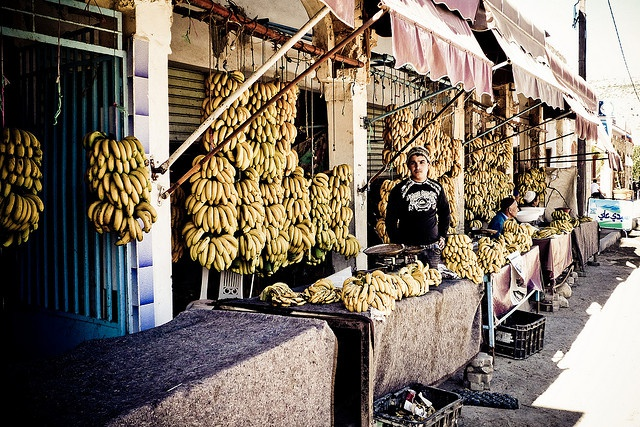Describe the objects in this image and their specific colors. I can see banana in black, khaki, beige, and tan tones, people in black, ivory, gray, and darkgray tones, banana in black, olive, and maroon tones, banana in black, beige, khaki, and tan tones, and banana in black, khaki, tan, and beige tones in this image. 